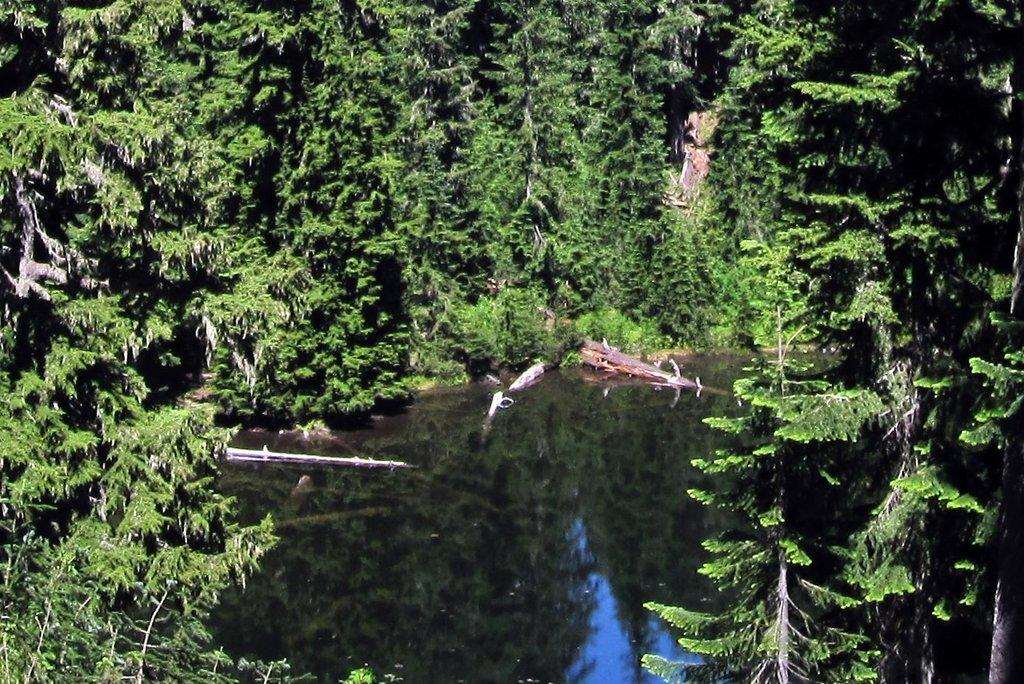What is located at the bottom of the image? There is a pond at the bottom of the image. What can be seen in the background of the image? There are trees in the background of the image. Is there a spy hiding in the trees in the image? There is no indication of a spy or any hidden figures in the image; it only shows trees in the background. 